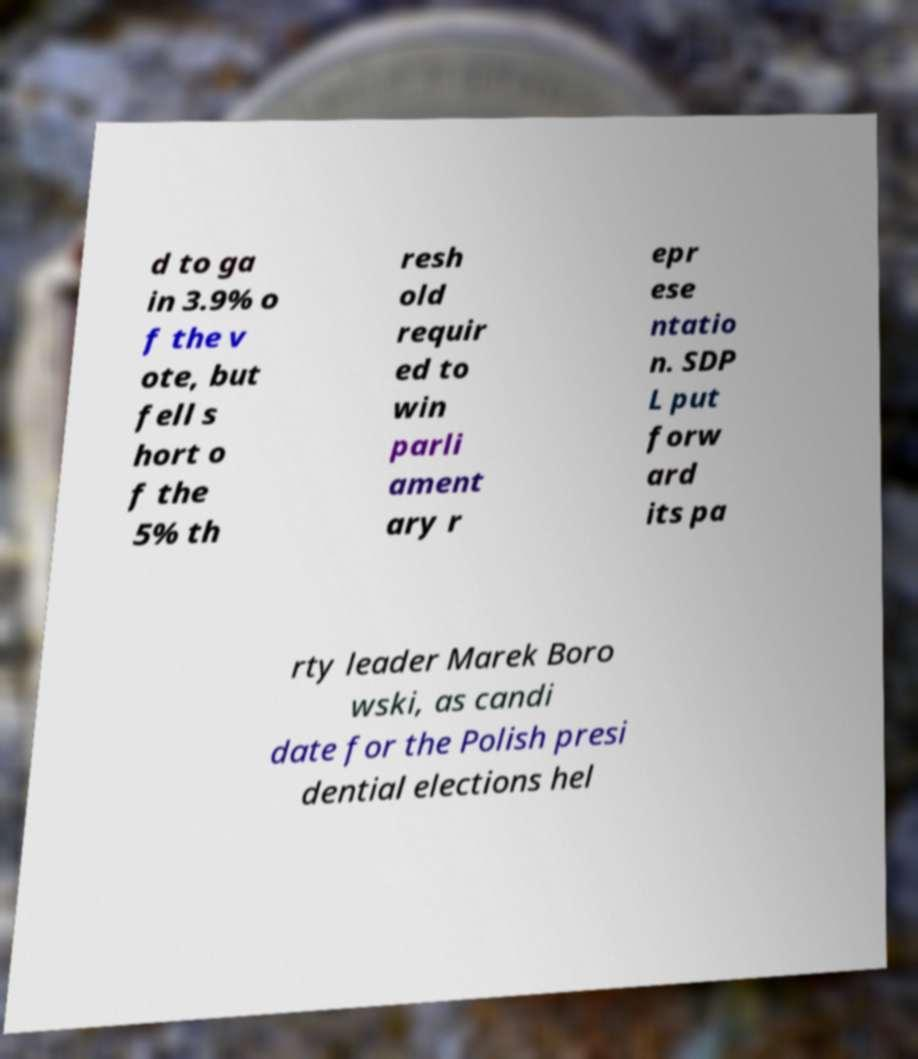Please read and relay the text visible in this image. What does it say? d to ga in 3.9% o f the v ote, but fell s hort o f the 5% th resh old requir ed to win parli ament ary r epr ese ntatio n. SDP L put forw ard its pa rty leader Marek Boro wski, as candi date for the Polish presi dential elections hel 